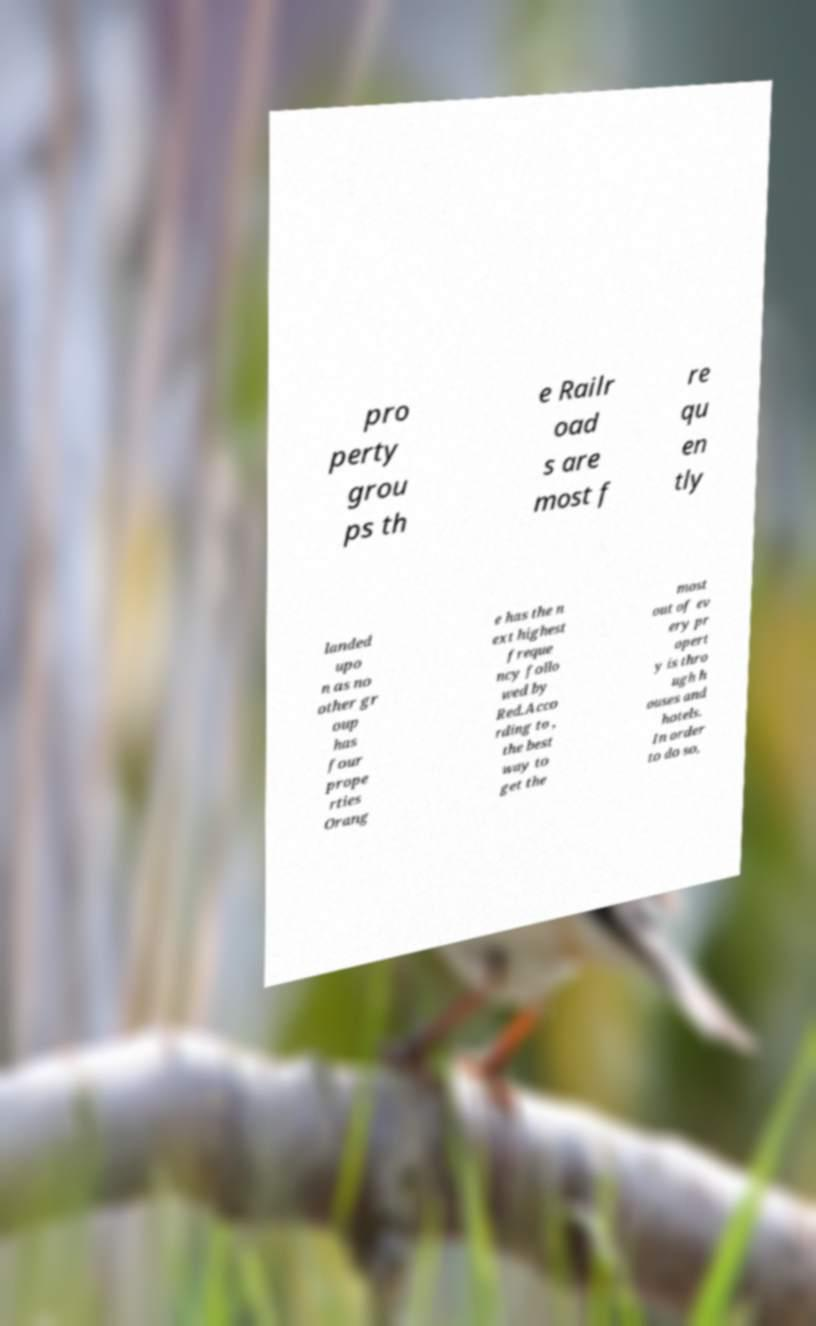I need the written content from this picture converted into text. Can you do that? pro perty grou ps th e Railr oad s are most f re qu en tly landed upo n as no other gr oup has four prope rties Orang e has the n ext highest freque ncy follo wed by Red.Acco rding to , the best way to get the most out of ev ery pr opert y is thro ugh h ouses and hotels. In order to do so, 